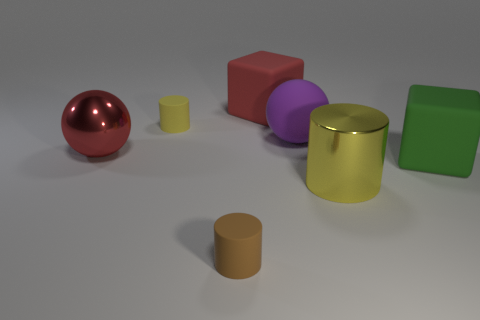Subtract all yellow cylinders. How many cylinders are left? 1 Add 2 small red matte cylinders. How many objects exist? 9 Subtract all cylinders. How many objects are left? 4 Add 4 matte cubes. How many matte cubes exist? 6 Subtract 0 blue spheres. How many objects are left? 7 Subtract all tiny blue spheres. Subtract all small brown cylinders. How many objects are left? 6 Add 5 big rubber objects. How many big rubber objects are left? 8 